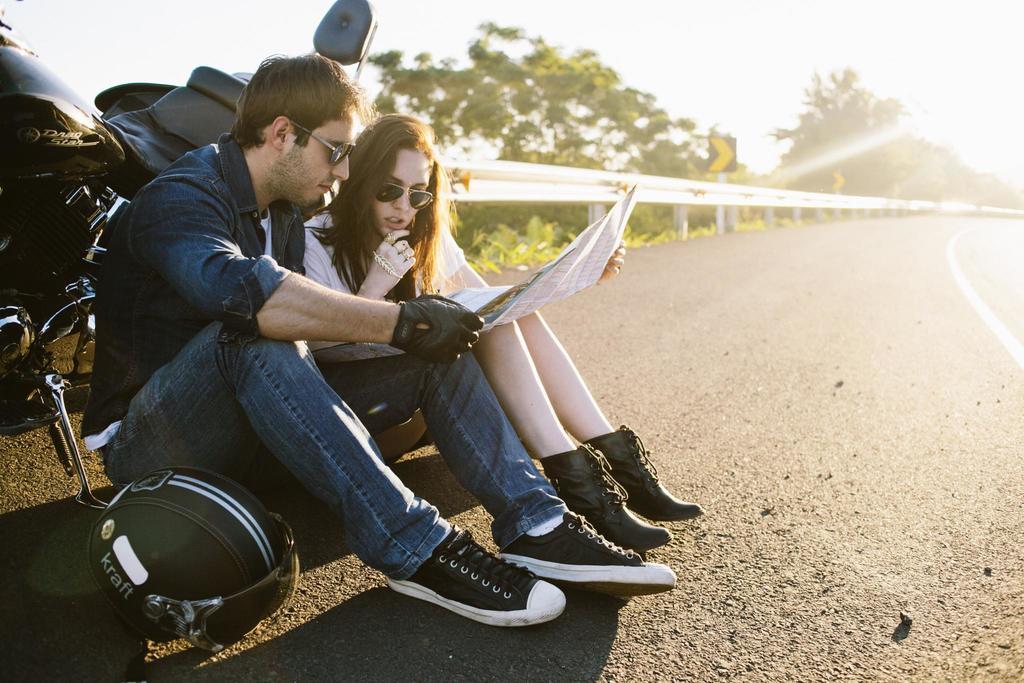How would you summarize this image in a sentence or two? In this image we can see a man and a woman sitting on a road and looking into a paper, beside the man there is a helmet and behind them there is a motorbike and there is a an iron railing, trees and the sky. 